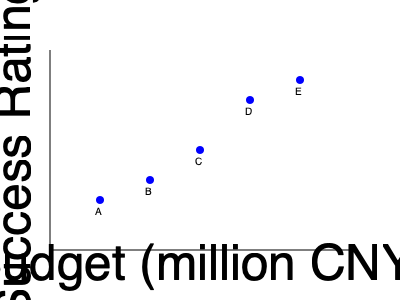In the scatter plot above, which shows the relationship between a drama's budget and its success rating, what type of correlation is observed? How might this information be relevant to Gong Jun's career choices in business dramas? To determine the correlation in the scatter plot, we need to analyze the pattern of the data points:

1. Observe the overall trend: As we move from left to right (increasing budget), the points generally move upward (increasing success rating).

2. Consistency of the trend: The upward trend is fairly consistent across all data points, without any significant outliers or changes in direction.

3. Strength of the relationship: The points form a relatively tight pattern, indicating a strong relationship between budget and success rating.

4. Direction of the relationship: As one variable increases, the other also increases, indicating a positive relationship.

5. Linear vs. Non-linear: The relationship appears to be approximately linear, as the points roughly follow a straight line.

Based on these observations, we can conclude that there is a strong positive linear correlation between a drama's budget and its success rating.

Relevance to Gong Jun's career in business dramas:

1. Career decisions: Gong Jun might consider prioritizing roles in higher-budget productions, as they tend to be more successful.

2. Industry trends: Understanding this correlation could help Gong Jun anticipate which business dramas are likely to be more successful and popular.

3. Negotiation power: For business dramas with larger budgets, Gong Jun might have more leverage in negotiating better contracts or roles.

4. Long-term strategy: Focusing on high-budget business dramas could potentially lead to more successful projects and increased popularity for Gong Jun.

5. Risk assessment: While higher budgets correlate with success, Gong Jun should also consider other factors that contribute to a drama's success when choosing roles.
Answer: Strong positive linear correlation 